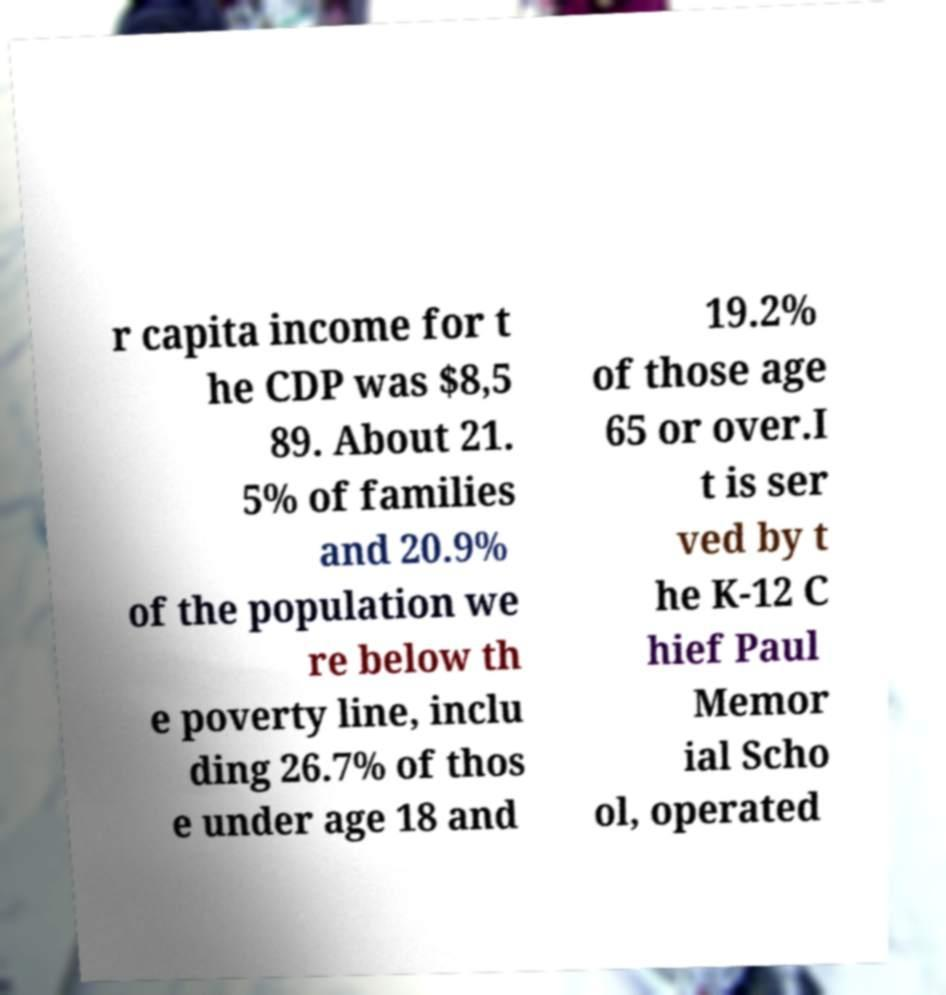What messages or text are displayed in this image? I need them in a readable, typed format. r capita income for t he CDP was $8,5 89. About 21. 5% of families and 20.9% of the population we re below th e poverty line, inclu ding 26.7% of thos e under age 18 and 19.2% of those age 65 or over.I t is ser ved by t he K-12 C hief Paul Memor ial Scho ol, operated 